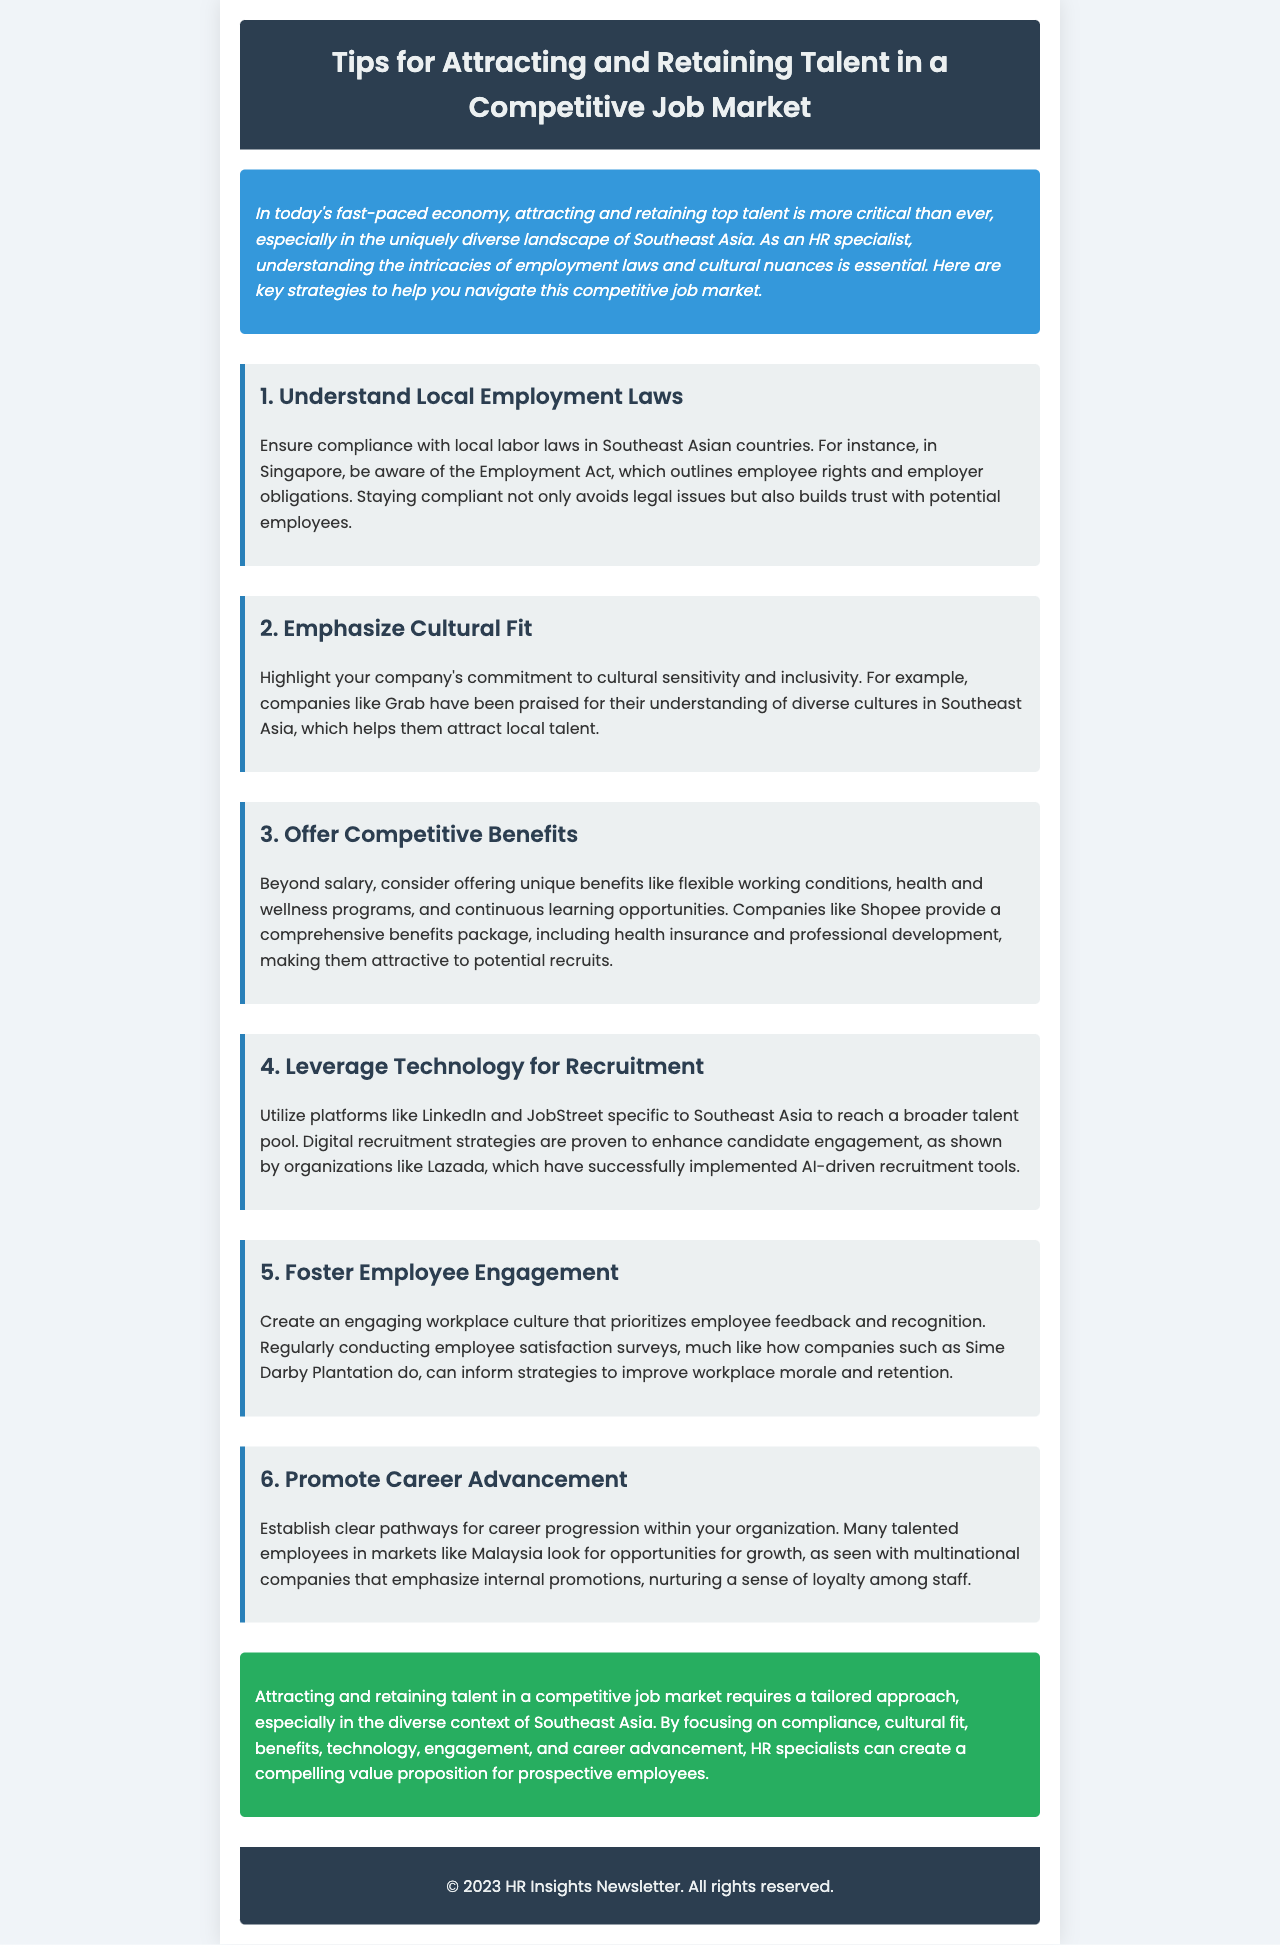What is the title of the newsletter? The title is presented prominently at the top of the document, providing the main topic.
Answer: Tips for Attracting and Retaining Talent in a Competitive Job Market Which country is mentioned in relation to the Employment Act? This question asks for a specific mention of a country that has a law discussed in the newsletter.
Answer: Singapore What company is noted for its commitment to cultural sensitivity? This question refers to a company highlighted in the cultural fit section, illustrating a successful example.
Answer: Grab What is a unique benefit mentioned for attracting talent? This asks for a specific type of benefit that goes beyond salary provided in the benefits section.
Answer: Flexible working conditions Which recruitment platforms are suggested for leveraging technology? This question requires recalling specific platforms mentioned for recruitment strategies.
Answer: LinkedIn and JobStreet What is one strategy companies use to foster employee engagement? This asks for a specific method highlighted in the workplace engagement section.
Answer: Employee satisfaction surveys Which country's market is mentioned regarding opportunities for growth? This question pertains to a specific country highlighted in the career advancement discussion.
Answer: Malaysia What color is used for the introduction section? This inquires about the visual aspect of the newsletter, specifically the color used in the introduction.
Answer: Blue Who conducted employee satisfaction surveys as mentioned in the document? This question looks for a specific company highlighted in the engagement section that uses surveys.
Answer: Sime Darby Plantation 